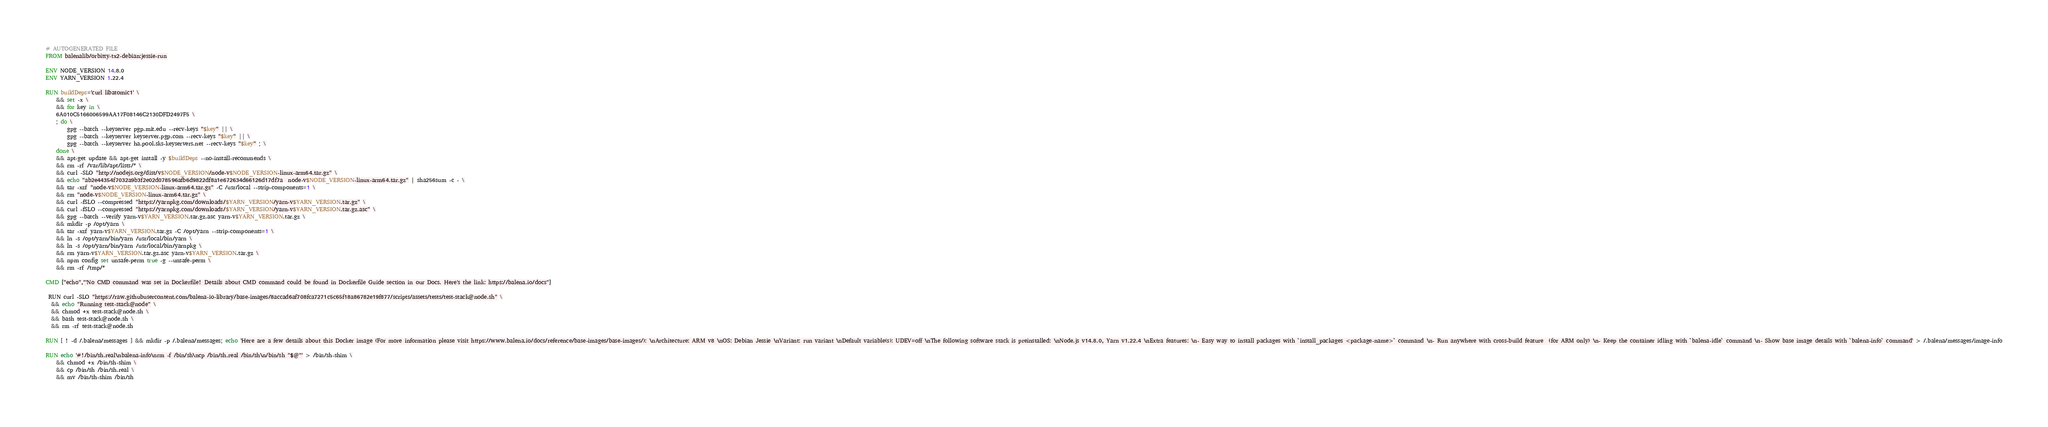Convert code to text. <code><loc_0><loc_0><loc_500><loc_500><_Dockerfile_># AUTOGENERATED FILE
FROM balenalib/orbitty-tx2-debian:jessie-run

ENV NODE_VERSION 14.8.0
ENV YARN_VERSION 1.22.4

RUN buildDeps='curl libatomic1' \
	&& set -x \
	&& for key in \
	6A010C5166006599AA17F08146C2130DFD2497F5 \
	; do \
		gpg --batch --keyserver pgp.mit.edu --recv-keys "$key" || \
		gpg --batch --keyserver keyserver.pgp.com --recv-keys "$key" || \
		gpg --batch --keyserver ha.pool.sks-keyservers.net --recv-keys "$key" ; \
	done \
	&& apt-get update && apt-get install -y $buildDeps --no-install-recommends \
	&& rm -rf /var/lib/apt/lists/* \
	&& curl -SLO "http://nodejs.org/dist/v$NODE_VERSION/node-v$NODE_VERSION-linux-arm64.tar.gz" \
	&& echo "ab2e44354f7032a9b3f2e02d078596afb6d9822df8a1e672634d66126d17df7a  node-v$NODE_VERSION-linux-arm64.tar.gz" | sha256sum -c - \
	&& tar -xzf "node-v$NODE_VERSION-linux-arm64.tar.gz" -C /usr/local --strip-components=1 \
	&& rm "node-v$NODE_VERSION-linux-arm64.tar.gz" \
	&& curl -fSLO --compressed "https://yarnpkg.com/downloads/$YARN_VERSION/yarn-v$YARN_VERSION.tar.gz" \
	&& curl -fSLO --compressed "https://yarnpkg.com/downloads/$YARN_VERSION/yarn-v$YARN_VERSION.tar.gz.asc" \
	&& gpg --batch --verify yarn-v$YARN_VERSION.tar.gz.asc yarn-v$YARN_VERSION.tar.gz \
	&& mkdir -p /opt/yarn \
	&& tar -xzf yarn-v$YARN_VERSION.tar.gz -C /opt/yarn --strip-components=1 \
	&& ln -s /opt/yarn/bin/yarn /usr/local/bin/yarn \
	&& ln -s /opt/yarn/bin/yarn /usr/local/bin/yarnpkg \
	&& rm yarn-v$YARN_VERSION.tar.gz.asc yarn-v$YARN_VERSION.tar.gz \
	&& npm config set unsafe-perm true -g --unsafe-perm \
	&& rm -rf /tmp/*

CMD ["echo","'No CMD command was set in Dockerfile! Details about CMD command could be found in Dockerfile Guide section in our Docs. Here's the link: https://balena.io/docs"]

 RUN curl -SLO "https://raw.githubusercontent.com/balena-io-library/base-images/8accad6af708fca7271c5c65f18a86782e19f877/scripts/assets/tests/test-stack@node.sh" \
  && echo "Running test-stack@node" \
  && chmod +x test-stack@node.sh \
  && bash test-stack@node.sh \
  && rm -rf test-stack@node.sh 

RUN [ ! -d /.balena/messages ] && mkdir -p /.balena/messages; echo 'Here are a few details about this Docker image (For more information please visit https://www.balena.io/docs/reference/base-images/base-images/): \nArchitecture: ARM v8 \nOS: Debian Jessie \nVariant: run variant \nDefault variable(s): UDEV=off \nThe following software stack is preinstalled: \nNode.js v14.8.0, Yarn v1.22.4 \nExtra features: \n- Easy way to install packages with `install_packages <package-name>` command \n- Run anywhere with cross-build feature  (for ARM only) \n- Keep the container idling with `balena-idle` command \n- Show base image details with `balena-info` command' > /.balena/messages/image-info

RUN echo '#!/bin/sh.real\nbalena-info\nrm -f /bin/sh\ncp /bin/sh.real /bin/sh\n/bin/sh "$@"' > /bin/sh-shim \
	&& chmod +x /bin/sh-shim \
	&& cp /bin/sh /bin/sh.real \
	&& mv /bin/sh-shim /bin/sh</code> 